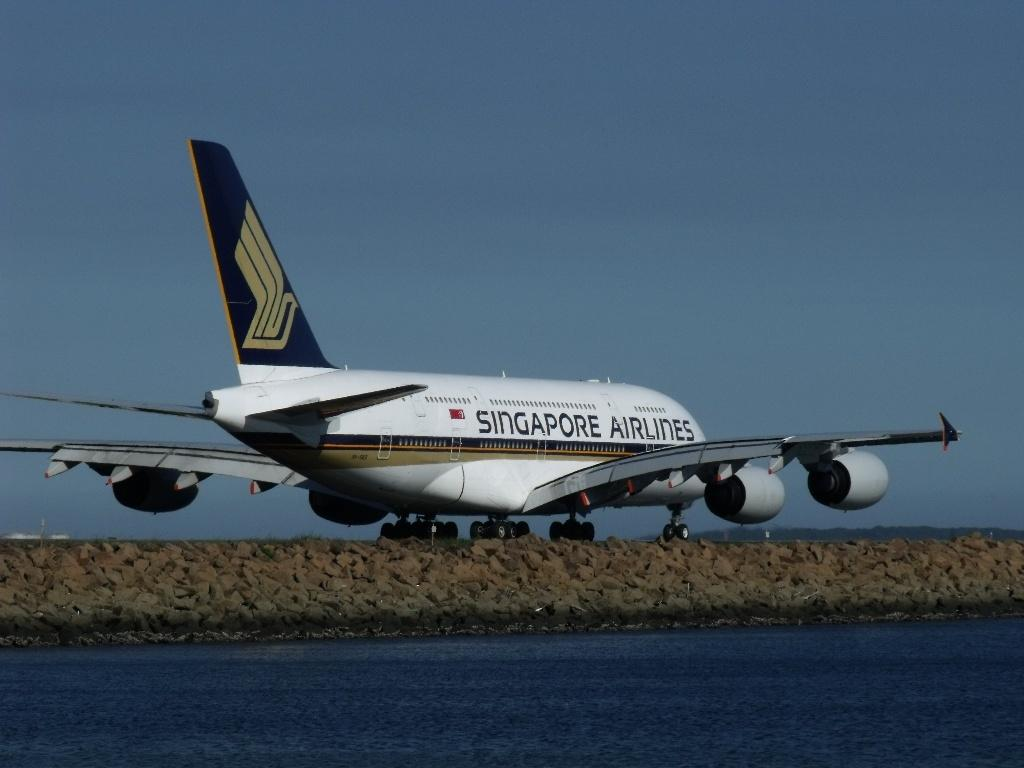What is the main subject of the image? The main subject of the image is an airplane. Where is the airplane located in the image? The airplane is on the ground in the image. What else can be seen in the image besides the airplane? There is water visible in the image. What type of meat is being served under the umbrella in the image? There is no meat or umbrella present in the image; it only features an airplane on the ground and water. 